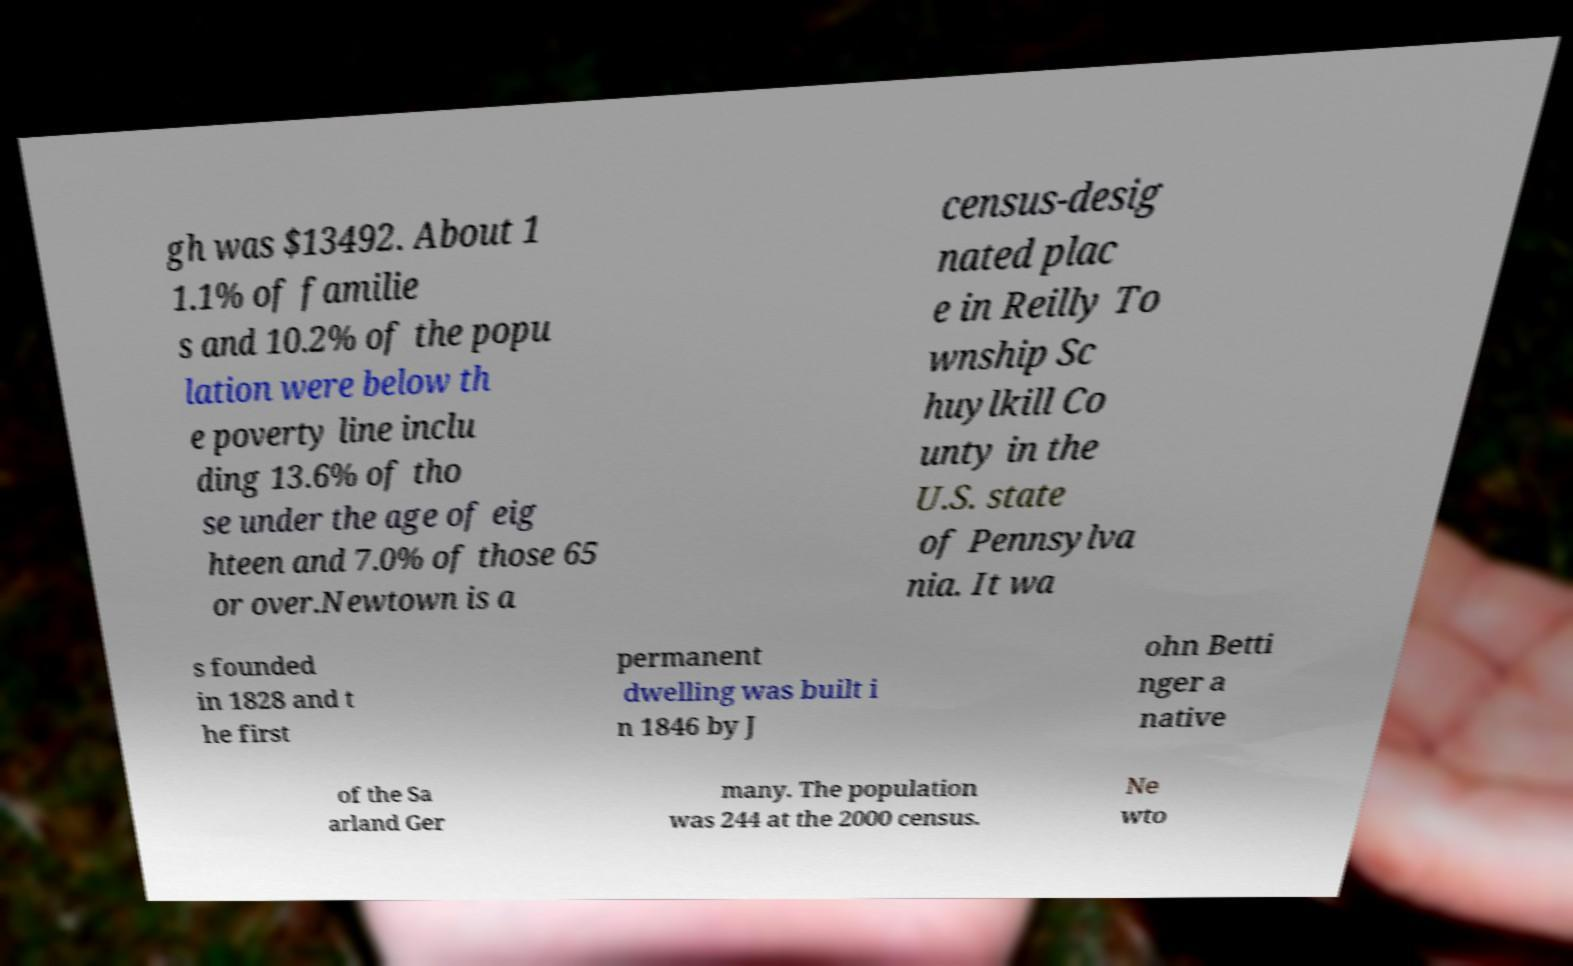There's text embedded in this image that I need extracted. Can you transcribe it verbatim? gh was $13492. About 1 1.1% of familie s and 10.2% of the popu lation were below th e poverty line inclu ding 13.6% of tho se under the age of eig hteen and 7.0% of those 65 or over.Newtown is a census-desig nated plac e in Reilly To wnship Sc huylkill Co unty in the U.S. state of Pennsylva nia. It wa s founded in 1828 and t he first permanent dwelling was built i n 1846 by J ohn Betti nger a native of the Sa arland Ger many. The population was 244 at the 2000 census. Ne wto 